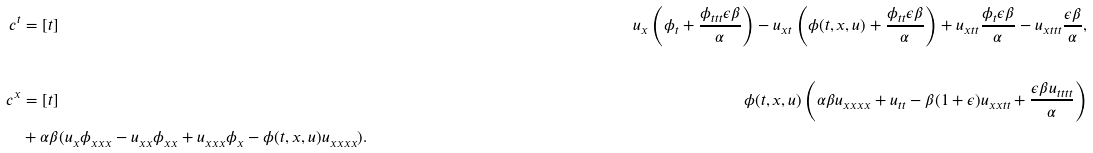<formula> <loc_0><loc_0><loc_500><loc_500>c ^ { t } & = [ t ] & u _ { x } \left ( \phi _ { t } + \frac { \phi _ { t t t } \epsilon \beta } { \alpha } \right ) - u _ { x t } \left ( \phi ( t , x , u ) + \frac { \phi _ { t t } \epsilon \beta } { \alpha } \right ) + u _ { x t t } \frac { \phi _ { t } \epsilon \beta } { \alpha } - u _ { x t t t } \frac { \epsilon \beta } { \alpha } , \\ \\ c ^ { x } & = [ t ] & \phi ( t , x , u ) \left ( \alpha \beta u _ { x x x x } + u _ { t t } - \beta ( 1 + \epsilon ) u _ { x x t t } + \frac { \epsilon \beta u _ { t t t t } } { \alpha } \right ) \\ & + \alpha \beta ( u _ { x } \phi _ { x x x } - u _ { x x } \phi _ { x x } + u _ { x x x } \phi _ { x } - \phi ( t , x , u ) u _ { x x x x } ) . \\ \\</formula> 